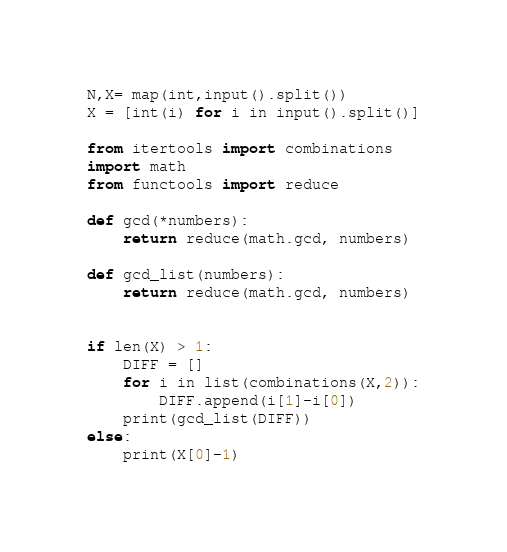Convert code to text. <code><loc_0><loc_0><loc_500><loc_500><_Python_>N,X= map(int,input().split())
X = [int(i) for i in input().split()]

from itertools import combinations
import math
from functools import reduce

def gcd(*numbers):
    return reduce(math.gcd, numbers)

def gcd_list(numbers):
    return reduce(math.gcd, numbers)


if len(X) > 1:
    DIFF = []
    for i in list(combinations(X,2)):
        DIFF.append(i[1]-i[0])
    print(gcd_list(DIFF))
else:
    print(X[0]-1)</code> 